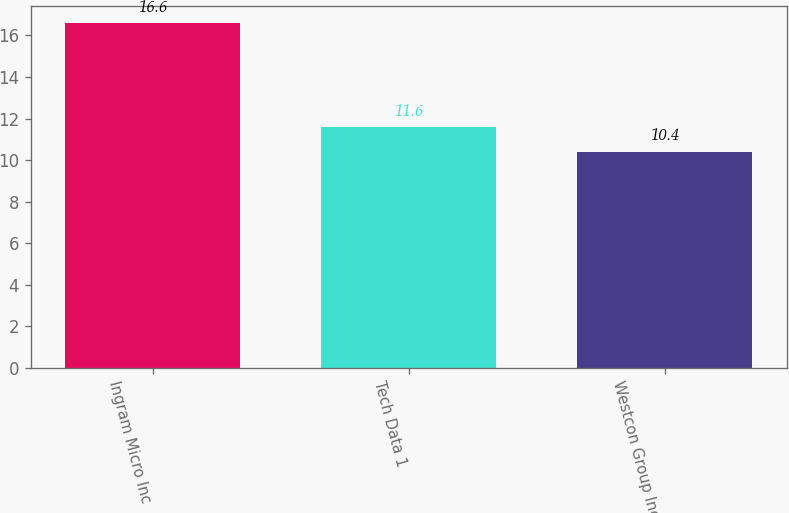Convert chart to OTSL. <chart><loc_0><loc_0><loc_500><loc_500><bar_chart><fcel>Ingram Micro Inc<fcel>Tech Data 1<fcel>Westcon Group Inc 2<nl><fcel>16.6<fcel>11.6<fcel>10.4<nl></chart> 